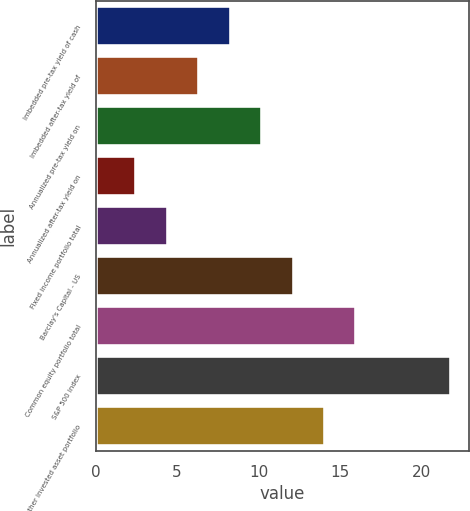<chart> <loc_0><loc_0><loc_500><loc_500><bar_chart><fcel>Imbedded pre-tax yield of cash<fcel>Imbedded after-tax yield of<fcel>Annualized pre-tax yield on<fcel>Annualized after-tax yield on<fcel>Fixed income portfolio total<fcel>Barclay's Capital - US<fcel>Common equity portfolio total<fcel>S&P 500 index<fcel>Other invested asset portfolio<nl><fcel>8.29<fcel>6.36<fcel>10.22<fcel>2.5<fcel>4.43<fcel>12.15<fcel>16.01<fcel>21.8<fcel>14.08<nl></chart> 